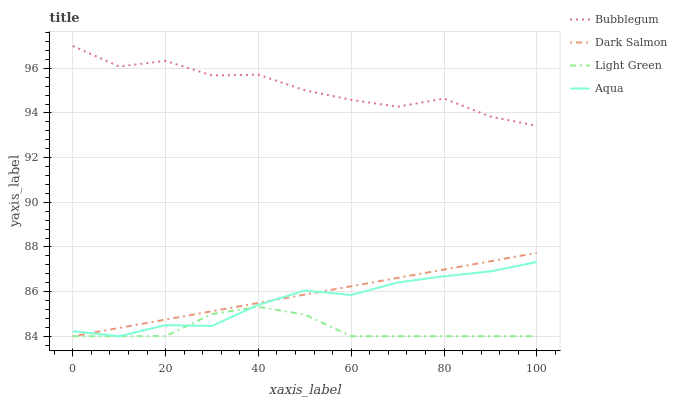Does Light Green have the minimum area under the curve?
Answer yes or no. Yes. Does Bubblegum have the maximum area under the curve?
Answer yes or no. Yes. Does Aqua have the minimum area under the curve?
Answer yes or no. No. Does Aqua have the maximum area under the curve?
Answer yes or no. No. Is Dark Salmon the smoothest?
Answer yes or no. Yes. Is Bubblegum the roughest?
Answer yes or no. Yes. Is Aqua the smoothest?
Answer yes or no. No. Is Aqua the roughest?
Answer yes or no. No. Does Light Green have the lowest value?
Answer yes or no. Yes. Does Bubblegum have the lowest value?
Answer yes or no. No. Does Bubblegum have the highest value?
Answer yes or no. Yes. Does Aqua have the highest value?
Answer yes or no. No. Is Light Green less than Bubblegum?
Answer yes or no. Yes. Is Bubblegum greater than Dark Salmon?
Answer yes or no. Yes. Does Aqua intersect Light Green?
Answer yes or no. Yes. Is Aqua less than Light Green?
Answer yes or no. No. Is Aqua greater than Light Green?
Answer yes or no. No. Does Light Green intersect Bubblegum?
Answer yes or no. No. 